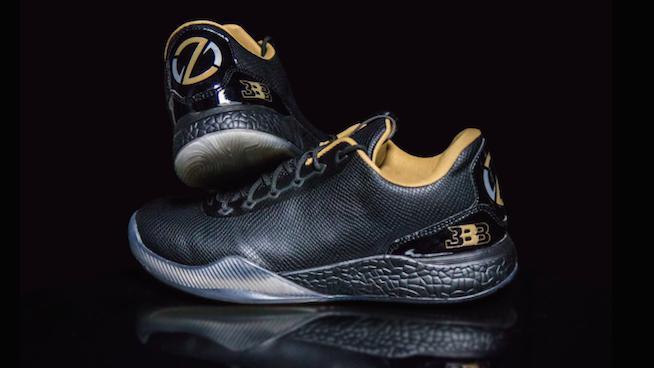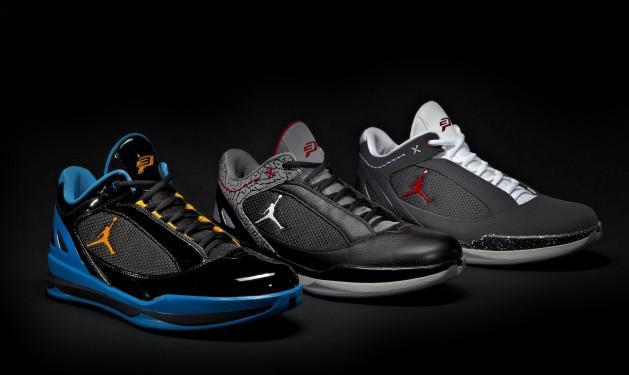The first image is the image on the left, the second image is the image on the right. Assess this claim about the two images: "There are more shoes in the image on the right.". Correct or not? Answer yes or no. Yes. The first image is the image on the left, the second image is the image on the right. For the images shown, is this caption "There are fewer than four shoes in total." true? Answer yes or no. No. 